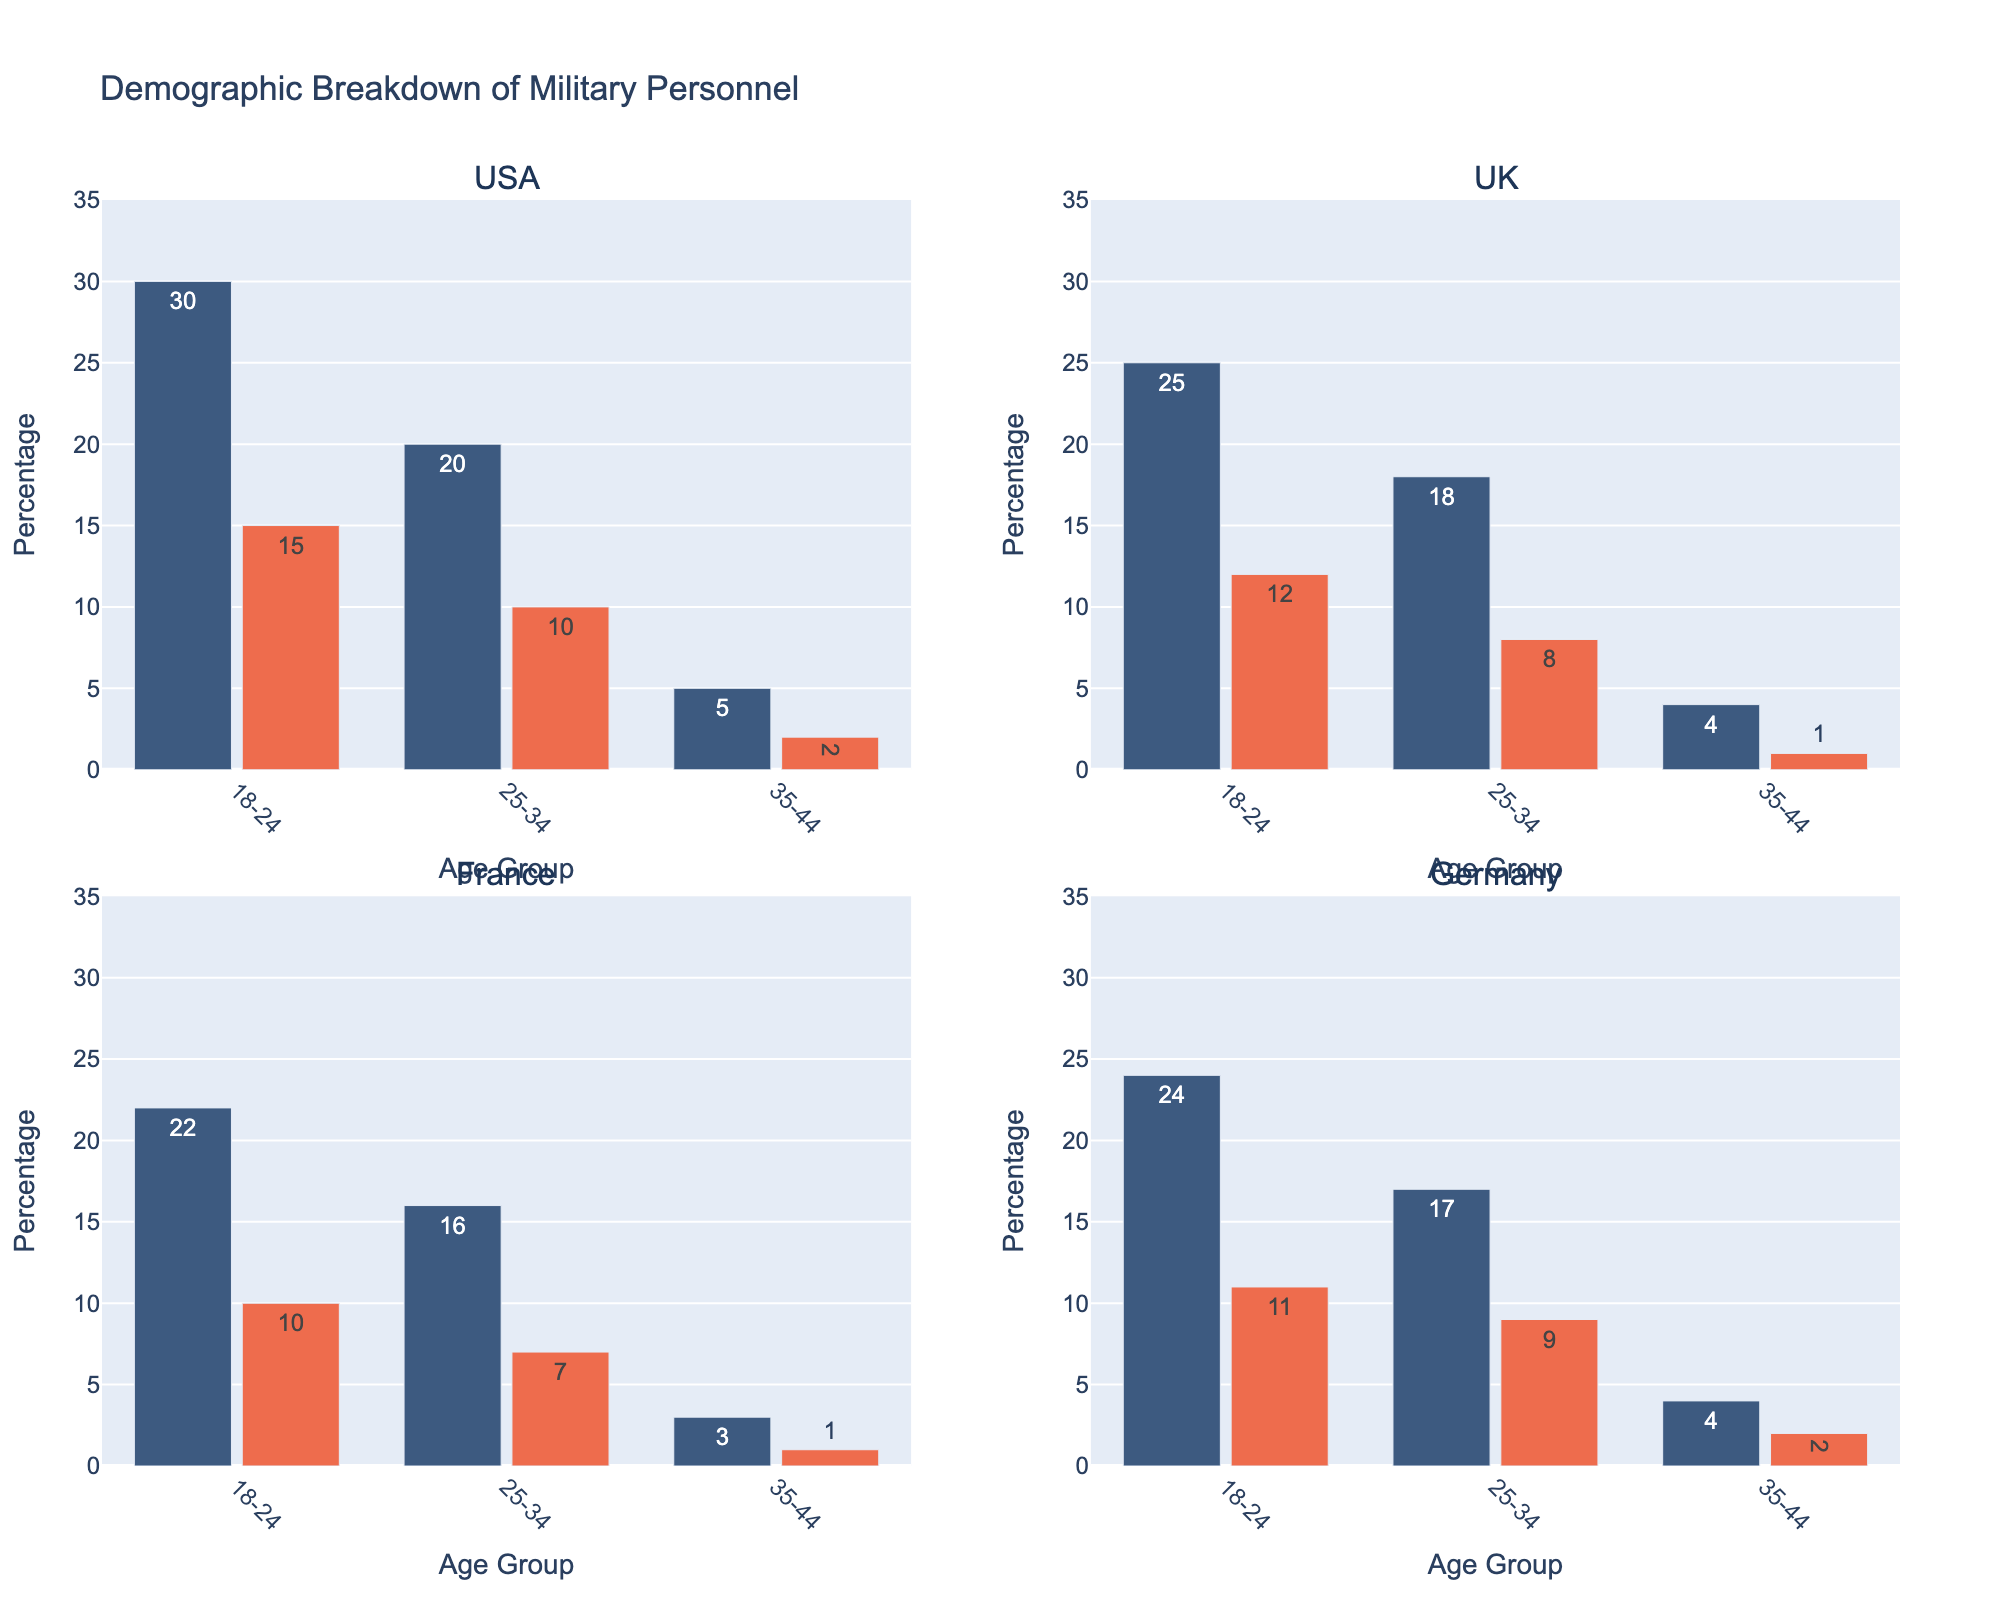What is the title of the figure? The title can be found at the top of the figure. It gives an overall summary of what the visual data represents. The title here is "User Engagement Metrics for Digital Art Tutorial Formats."
Answer: User Engagement Metrics for Digital Art Tutorial Formats Which tutorial format has the highest number of views? To determine this, look at the first subplot labeled "Views" and find the bar that is the highest. The highest bar corresponds to "Video Tutorials."
Answer: Video Tutorials What is the average watch time for Live Workshops? In the subplot labeled "Average Watch Time," locate the bar corresponding to "Live Workshops." The height of the bar represents the average watch time, which is 45.3 minutes.
Answer: 45.3 minutes Which tutorial format has the lowest completion rate and what is the rate? In the "Completion Rate" subplot, identify the shortest bar. The shortest bar corresponds to "PDF Manuals" with a completion rate of 45%.
Answer: PDF Manuals, 45% Compare the user ratings of Video Tutorials and Live Workshops. Which one is higher and by how much? In the subplot labeled "User Ratings," compare the heights of the bars for "Video Tutorials" and "Live Workshops." Live Workshops have a rating of 4.7, while Video Tutorials have a rating of 4.2. The difference is 4.7 - 4.2 = 0.5.
Answer: Live Workshops, 0.5 Which tutorial format has the second-highest number of views? In the "Views" subplot, identify the second tallest bar, which corresponds to "Interactive Guides" with 12,000 views.
Answer: Interactive Guides Calculate the sum of average watch times for Video Tutorials and Interactive Guides. Find the average watch time values for "Video Tutorials" (18.5) and "Interactive Guides" (22.7). Sum them up: 18.5 + 22.7 = 41.2 minutes.
Answer: 41.2 minutes Which tutorial format has a higher completion rate: Webinars or Step-by-Step Blog Posts? In the "Completion Rate" subplot, compare the heights of the bars for "Webinars" and "Step-by-Step Blog Posts." Webinars have a completion rate of 78%, while Step-by-Step Blog Posts have a completion rate of 55%, so Webinars are higher.
Answer: Webinars How many tutorial formats have a user rating above 4.0? In the "User Ratings" subplot, count the number of bars that have a height above 4.0. These include "Video Tutorials" (4.2), "Live Workshops" (4.7), "Interactive Guides" (4.1), and "Webinars" (4.4). So, there are four tutorial formats.
Answer: 4 Which tutorial format stands out in having the highest average watch time? In the "Average Watch Time" subplot, identify the tallest bar. The tallest bar corresponds to "Live Workshops," indicating it has the highest average watch time.
Answer: Live Workshops 